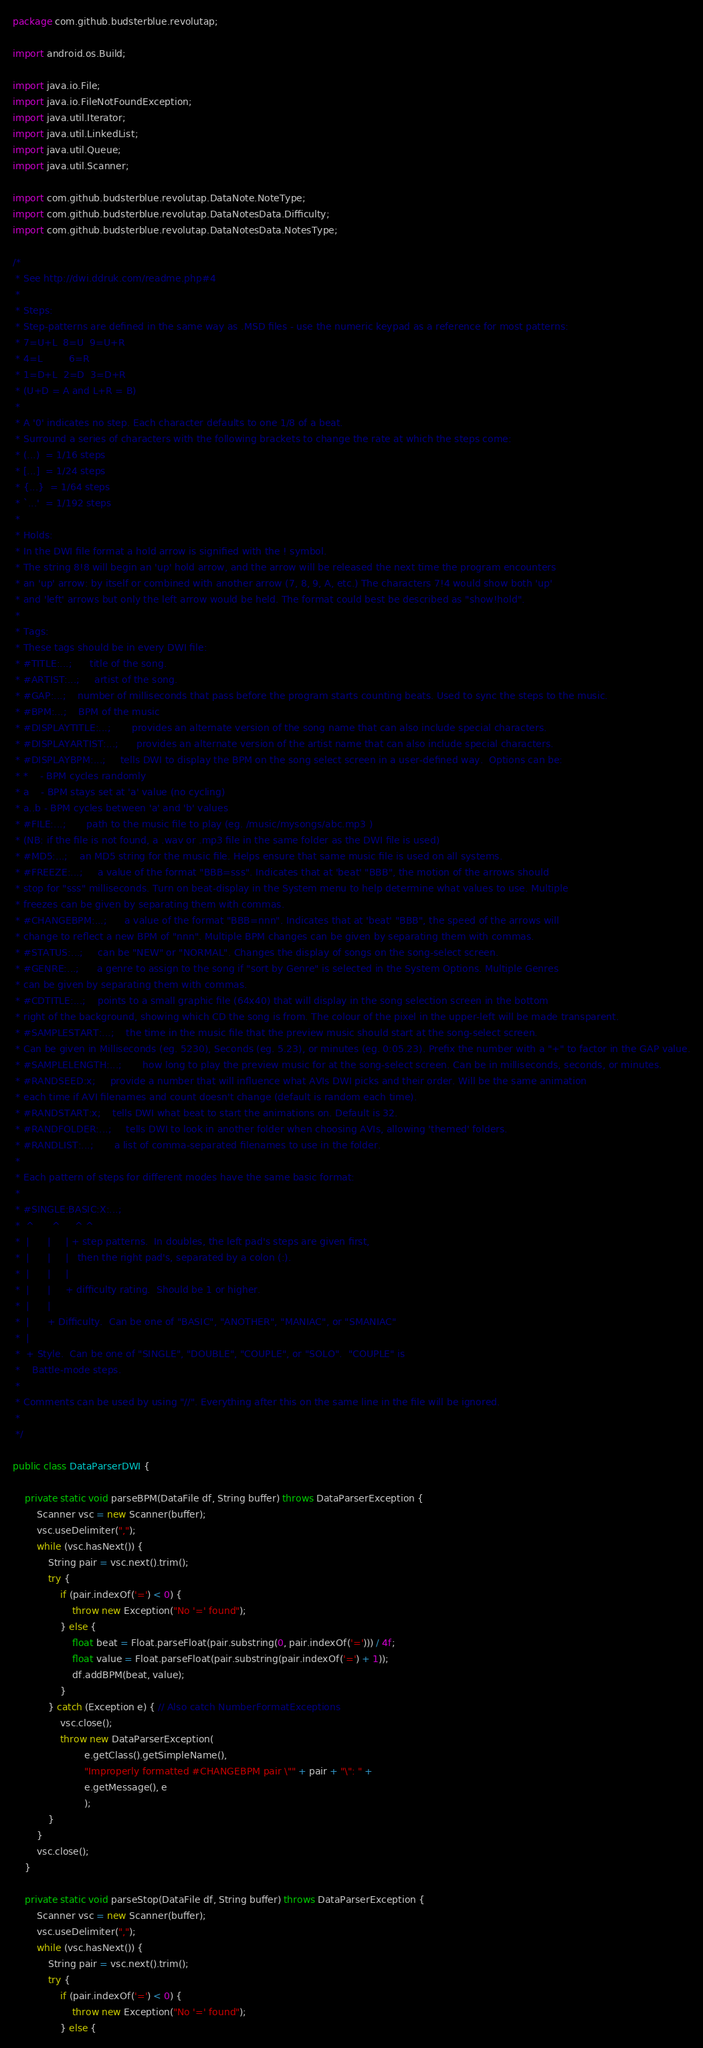Convert code to text. <code><loc_0><loc_0><loc_500><loc_500><_Java_>package com.github.budsterblue.revolutap;

import android.os.Build;

import java.io.File;
import java.io.FileNotFoundException;
import java.util.Iterator;
import java.util.LinkedList;
import java.util.Queue;
import java.util.Scanner;

import com.github.budsterblue.revolutap.DataNote.NoteType;
import com.github.budsterblue.revolutap.DataNotesData.Difficulty;
import com.github.budsterblue.revolutap.DataNotesData.NotesType;

/*
 * See http://dwi.ddruk.com/readme.php#4
 * 
 * Steps:
 * Step-patterns are defined in the same way as .MSD files - use the numeric keypad as a reference for most patterns:
 * 7=U+L  8=U  9=U+R
 * 4=L         6=R
 * 1=D+L  2=D  3=D+R
 * (U+D = A and L+R = B)
 * 
 * A '0' indicates no step. Each character defaults to one 1/8 of a beat.
 * Surround a series of characters with the following brackets to change the rate at which the steps come:
 * (...)  = 1/16 steps
 * [...]  = 1/24 steps
 * {...}  = 1/64 steps
 * `...'  = 1/192 steps
 * 
 * Holds:
 * In the DWI file format a hold arrow is signified with the ! symbol.
 * The string 8!8 will begin an 'up' hold arrow, and the arrow will be released the next time the program encounters
 * an 'up' arrow: by itself or combined with another arrow (7, 8, 9, A, etc.) The characters 7!4 would show both 'up'
 * and 'left' arrows but only the left arrow would be held. The format could best be described as "show!hold".
 *
 * Tags:
 * These tags should be in every DWI file:
 * #TITLE:...;  	title of the song.
 * #ARTIST:...;  	artist of the song.
 * #GAP:...;  	number of milliseconds that pass before the program starts counting beats. Used to sync the steps to the music.
 * #BPM:...;  	BPM of the music
 * #DISPLAYTITLE:...;   	provides an alternate version of the song name that can also include special characters.
 * #DISPLAYARTIST:...;  	provides an alternate version of the artist name that can also include special characters.
 * #DISPLAYBPM:...; 	tells DWI to display the BPM on the song select screen in a user-defined way.  Options can be:
 * *    - BPM cycles randomly
 * a    - BPM stays set at 'a' value (no cycling)
 * a..b - BPM cycles between 'a' and 'b' values
 * #FILE:...;   	path to the music file to play (eg. /music/mysongs/abc.mp3 )
 * (NB: if the file is not found, a .wav or .mp3 file in the same folder as the DWI file is used)
 * #MD5:...;   	an MD5 string for the music file. Helps ensure that same music file is used on all systems.
 * #FREEZE:...;   	a value of the format "BBB=sss". Indicates that at 'beat' "BBB", the motion of the arrows should
 * stop for "sss" milliseconds. Turn on beat-display in the System menu to help determine what values to use. Multiple
 * freezes can be given by separating them with commas.
 * #CHANGEBPM:...;   	a value of the format "BBB=nnn". Indicates that at 'beat' "BBB", the speed of the arrows will
 * change to reflect a new BPM of "nnn". Multiple BPM changes can be given by separating them with commas.
 * #STATUS:...;   	can be "NEW" or "NORMAL". Changes the display of songs on the song-select screen.
 * #GENRE:...;   	a genre to assign to the song if "sort by Genre" is selected in the System Options. Multiple Genres
 * can be given by separating them with commas.
 * #CDTITLE:...;   	points to a small graphic file (64x40) that will display in the song selection screen in the bottom
 * right of the background, showing which CD the song is from. The colour of the pixel in the upper-left will be made transparent.
 * #SAMPLESTART:...;   	the time in the music file that the preview music should start at the song-select screen.
 * Can be given in Milliseconds (eg. 5230), Seconds (eg. 5.23), or minutes (eg. 0:05.23). Prefix the number with a "+" to factor in the GAP value.
 * #SAMPLELENGTH:...;   	how long to play the preview music for at the song-select screen. Can be in milliseconds, seconds, or minutes.
 * #RANDSEED:x;   	provide a number that will influence what AVIs DWI picks and their order. Will be the same animation
 * each time if AVI filenames and count doesn't change (default is random each time).
 * #RANDSTART:x;   	tells DWI what beat to start the animations on. Default is 32.
 * #RANDFOLDER:...;   	tells DWI to look in another folder when choosing AVIs, allowing 'themed' folders.
 * #RANDLIST:...;   	a list of comma-separated filenames to use in the folder.
 * 
 * Each pattern of steps for different modes have the same basic format:
 * 
 * #SINGLE:BASIC:X:...;
 *  ^      ^     ^ ^
 *  |      |     | + step patterns.  In doubles, the left pad's steps are given first, 
 *  |      |     |   then the right pad's, separated by a colon (:).
 *  |      |     |
 *  |      |     + difficulty rating.  Should be 1 or higher.
 *  |      |
 *  |      + Difficulty.  Can be one of "BASIC", "ANOTHER", "MANIAC", or "SMANIAC"
 *  |
 *  + Style.  Can be one of "SINGLE", "DOUBLE", "COUPLE", or "SOLO".  "COUPLE" is 
 *    Battle-mode steps.
 * 
 * Comments can be used by using "//". Everything after this on the same line in the file will be ignored.
 * 
 */

public class DataParserDWI {
	
	private static void parseBPM(DataFile df, String buffer) throws DataParserException {
		Scanner vsc = new Scanner(buffer);
		vsc.useDelimiter(",");
		while (vsc.hasNext()) {
			String pair = vsc.next().trim();
			try {
				if (pair.indexOf('=') < 0) {
					throw new Exception("No '=' found");
				} else {
					float beat = Float.parseFloat(pair.substring(0, pair.indexOf('='))) / 4f;
					float value = Float.parseFloat(pair.substring(pair.indexOf('=') + 1));
					df.addBPM(beat, value);
				}
			} catch (Exception e) { // Also catch NumberFormatExceptions
				vsc.close();
				throw new DataParserException(
						e.getClass().getSimpleName(),
						"Improperly formatted #CHANGEBPM pair \"" + pair + "\": " +
						e.getMessage(), e
						);
			}
		}
		vsc.close();
	}
	
	private static void parseStop(DataFile df, String buffer) throws DataParserException {
		Scanner vsc = new Scanner(buffer);
		vsc.useDelimiter(",");
		while (vsc.hasNext()) {
			String pair = vsc.next().trim();
			try {
				if (pair.indexOf('=') < 0) {
					throw new Exception("No '=' found");
				} else {</code> 